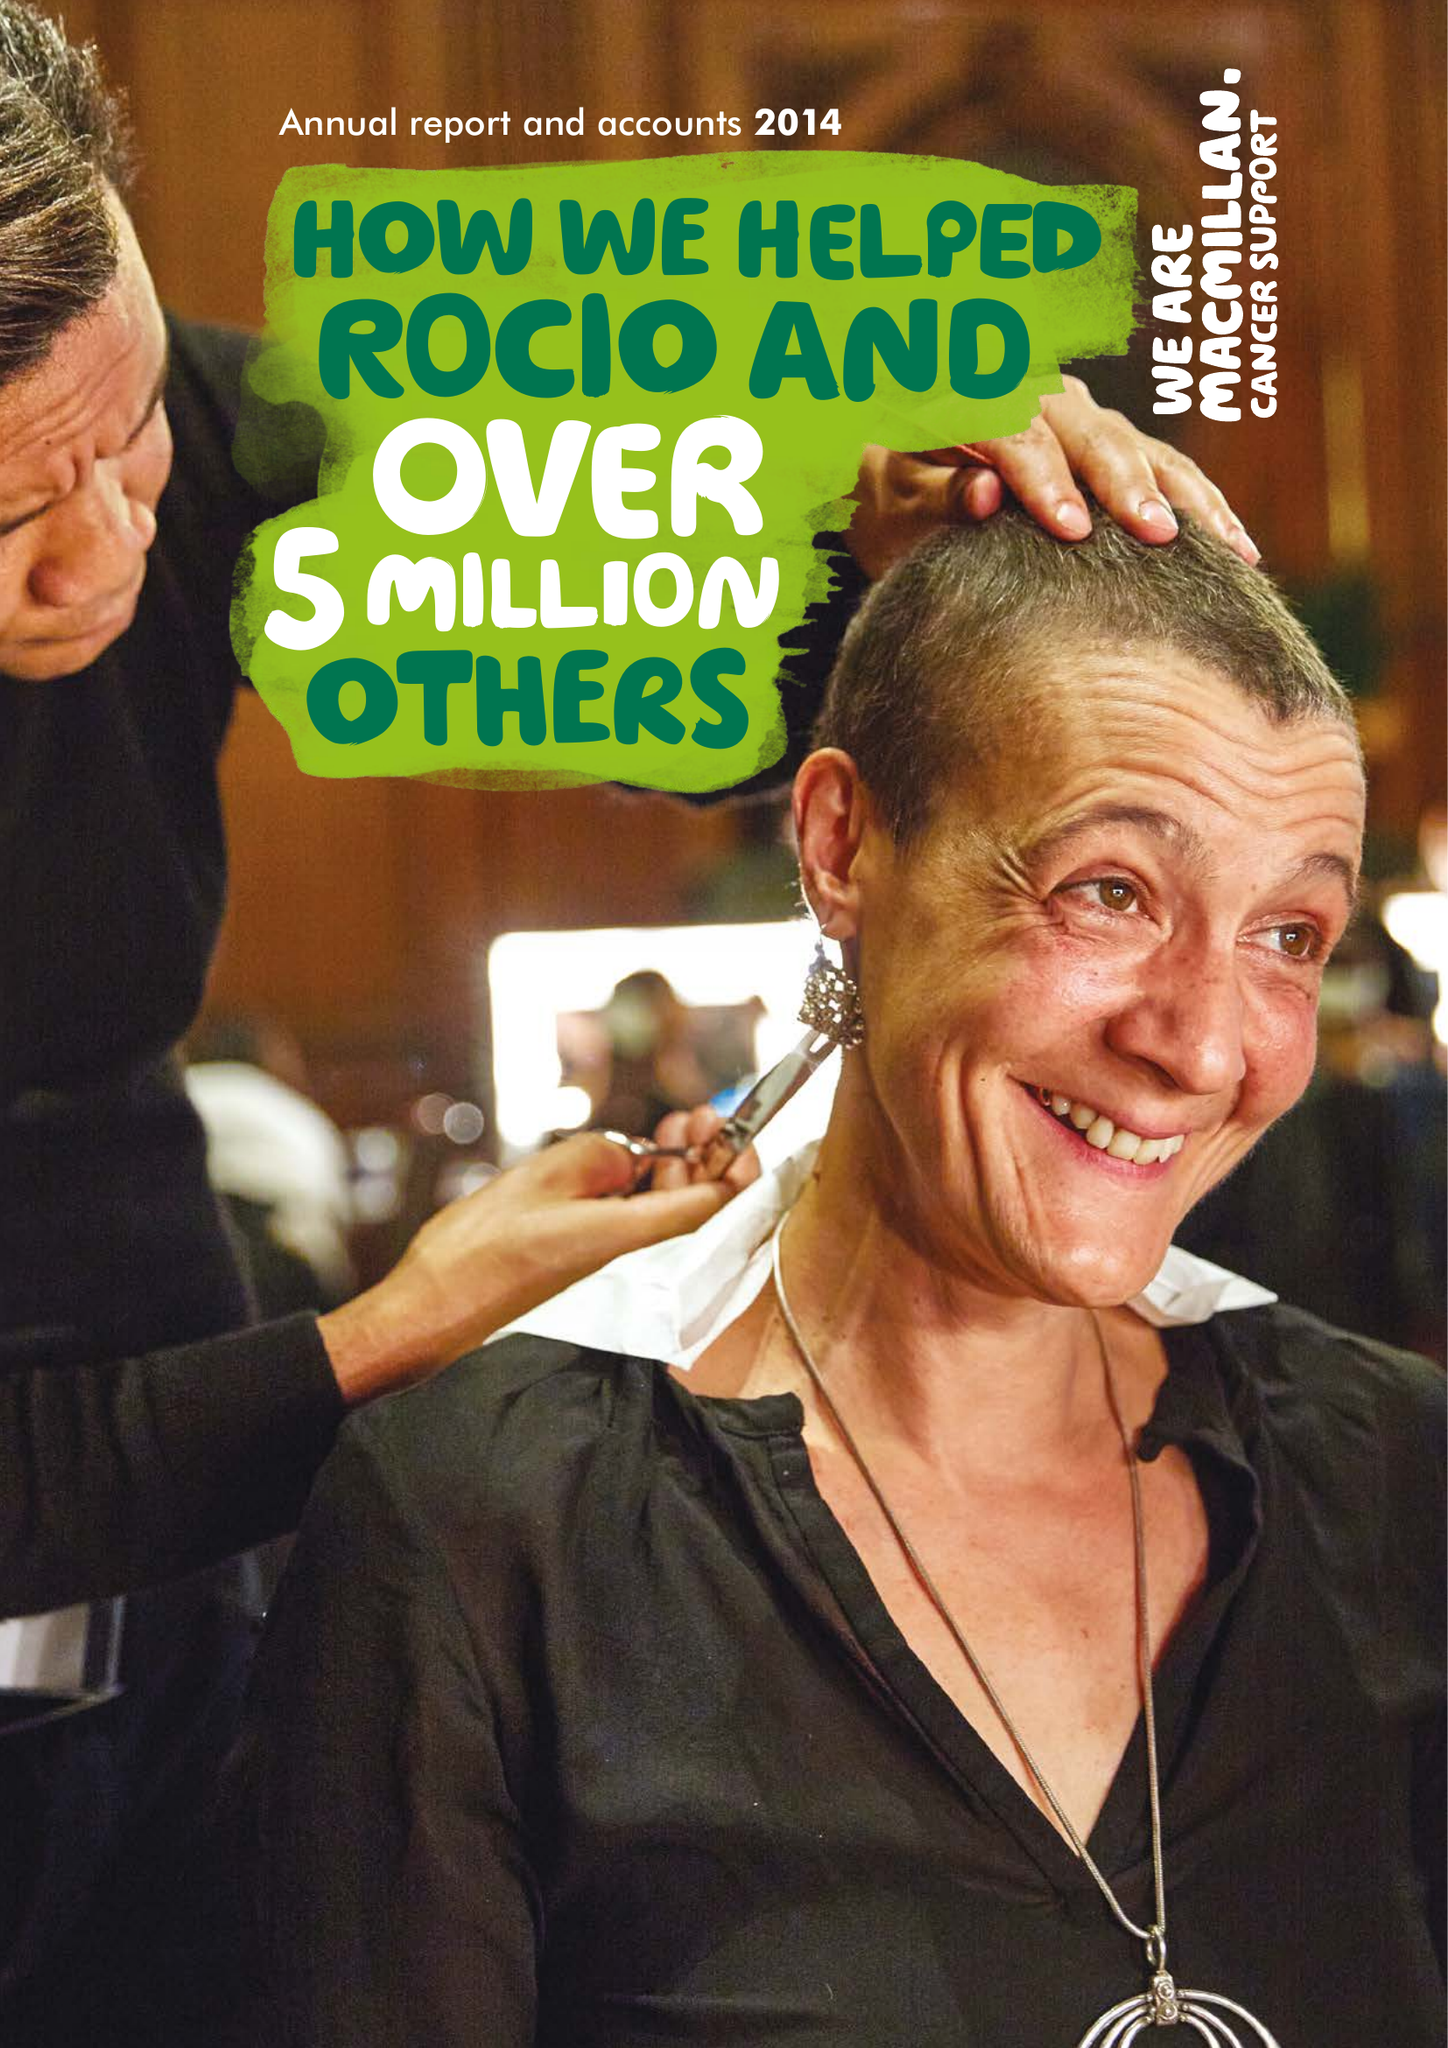What is the value for the address__street_line?
Answer the question using a single word or phrase. 87-90 ALBERT EMBANKMENT 